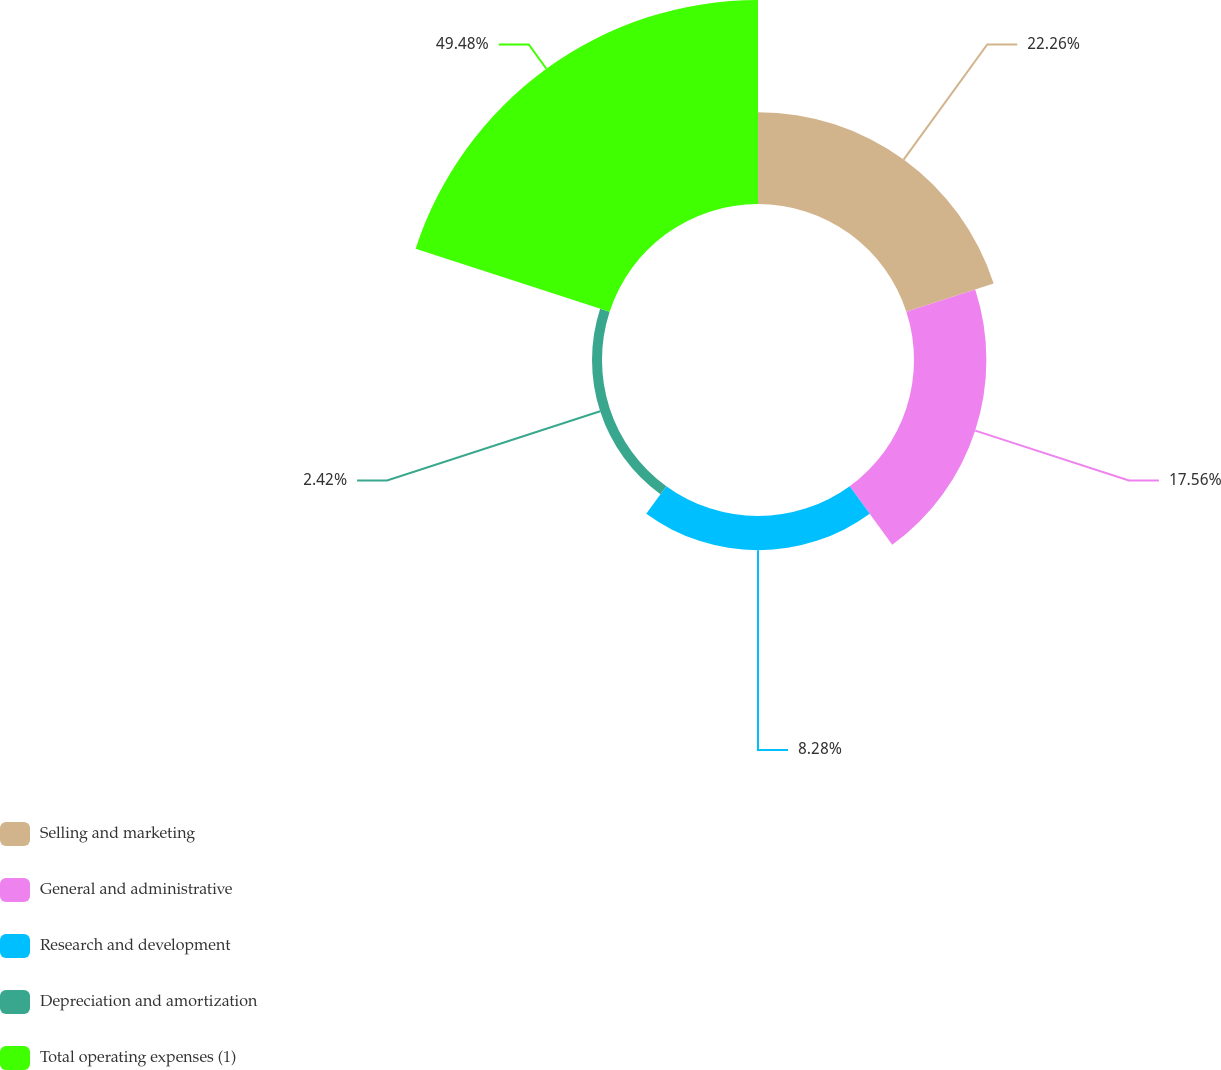<chart> <loc_0><loc_0><loc_500><loc_500><pie_chart><fcel>Selling and marketing<fcel>General and administrative<fcel>Research and development<fcel>Depreciation and amortization<fcel>Total operating expenses (1)<nl><fcel>22.26%<fcel>17.56%<fcel>8.28%<fcel>2.42%<fcel>49.48%<nl></chart> 